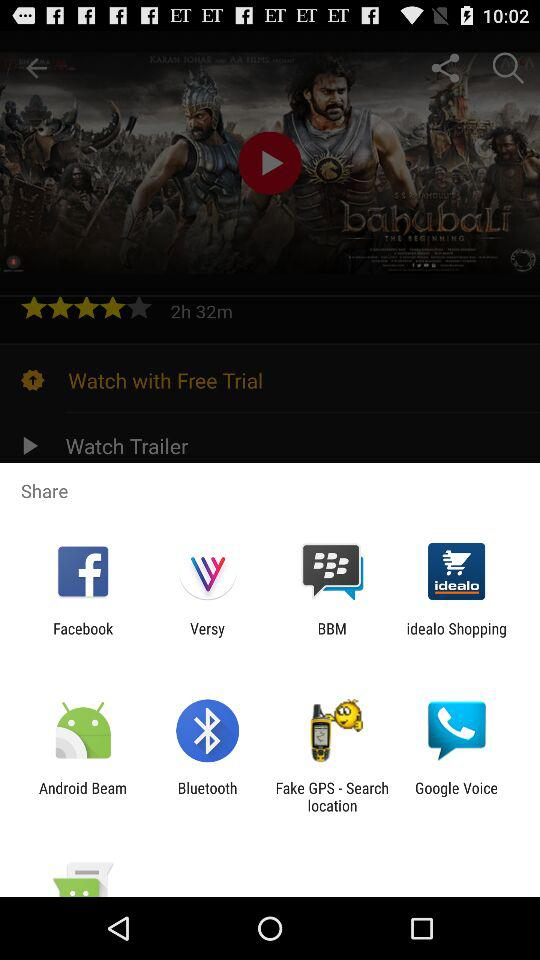What is the rating of the movie? The rating is 4 stars. 